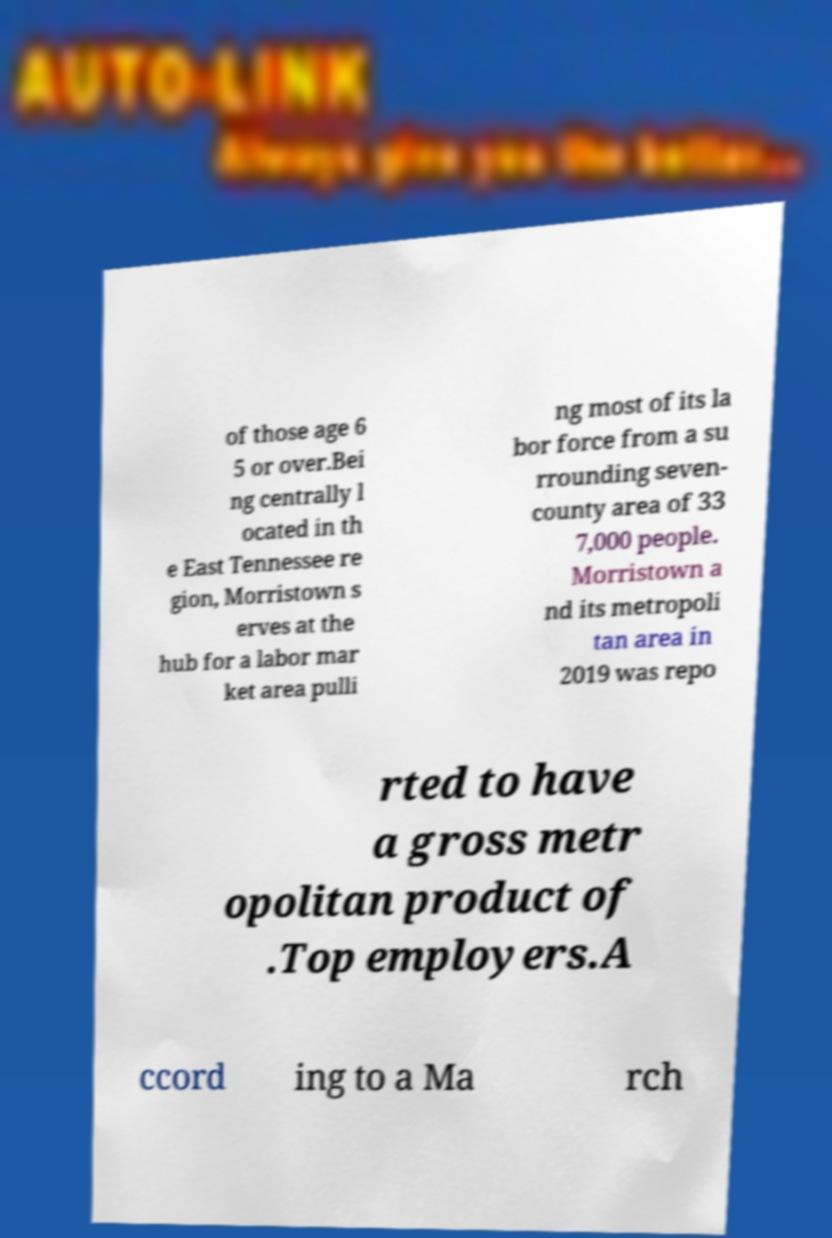Could you extract and type out the text from this image? of those age 6 5 or over.Bei ng centrally l ocated in th e East Tennessee re gion, Morristown s erves at the hub for a labor mar ket area pulli ng most of its la bor force from a su rrounding seven- county area of 33 7,000 people. Morristown a nd its metropoli tan area in 2019 was repo rted to have a gross metr opolitan product of .Top employers.A ccord ing to a Ma rch 